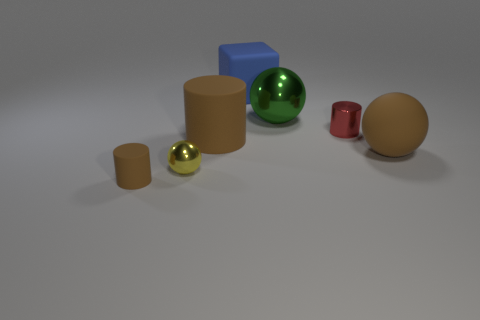There is a matte object that is right of the small red object; are there any big blue matte objects right of it?
Provide a succinct answer. No. There is a brown rubber object that is both behind the small yellow metallic ball and to the left of the large blue rubber thing; what is its size?
Provide a succinct answer. Large. How many blue objects are rubber things or metal cylinders?
Give a very brief answer. 1. The brown object that is the same size as the red shiny cylinder is what shape?
Ensure brevity in your answer.  Cylinder. How many other objects are the same color as the small sphere?
Offer a terse response. 0. What is the size of the rubber object in front of the ball in front of the big matte ball?
Make the answer very short. Small. Is the material of the tiny cylinder that is behind the small brown rubber cylinder the same as the green object?
Your answer should be compact. Yes. The matte object that is left of the large brown matte cylinder has what shape?
Ensure brevity in your answer.  Cylinder. What number of rubber cylinders are the same size as the red shiny thing?
Give a very brief answer. 1. The cube has what size?
Your response must be concise. Large. 